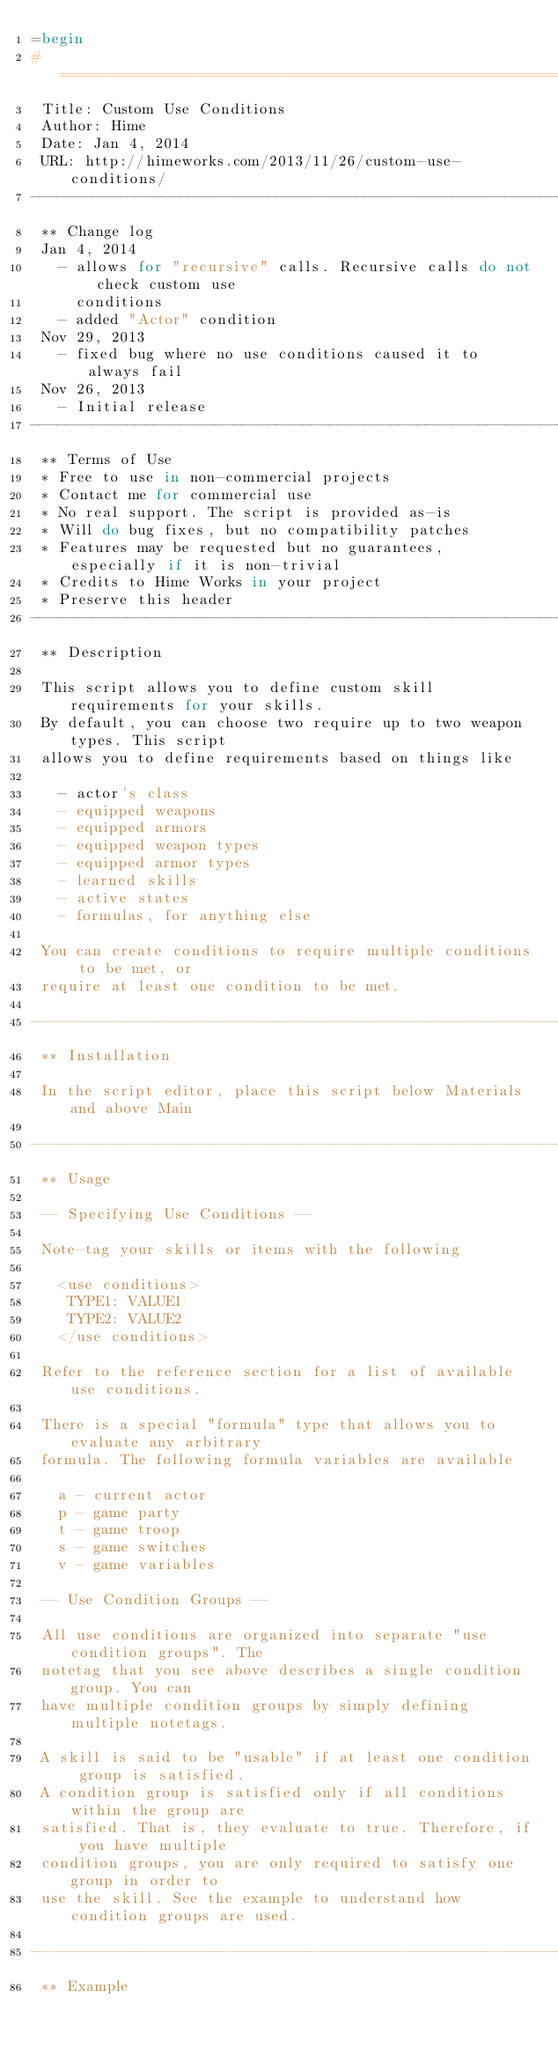Convert code to text. <code><loc_0><loc_0><loc_500><loc_500><_Ruby_>=begin
#===============================================================================
 Title: Custom Use Conditions
 Author: Hime
 Date: Jan 4, 2014
 URL: http://himeworks.com/2013/11/26/custom-use-conditions/
--------------------------------------------------------------------------------
 ** Change log
 Jan 4, 2014
   - allows for "recursive" calls. Recursive calls do not check custom use
     conditions
   - added "Actor" condition
 Nov 29, 2013
   - fixed bug where no use conditions caused it to always fail
 Nov 26, 2013
   - Initial release
--------------------------------------------------------------------------------   
 ** Terms of Use
 * Free to use in non-commercial projects
 * Contact me for commercial use
 * No real support. The script is provided as-is
 * Will do bug fixes, but no compatibility patches
 * Features may be requested but no guarantees, especially if it is non-trivial
 * Credits to Hime Works in your project
 * Preserve this header
--------------------------------------------------------------------------------
 ** Description
 
 This script allows you to define custom skill requirements for your skills.
 By default, you can choose two require up to two weapon types. This script
 allows you to define requirements based on things like
 
   - actor's class
   - equipped weapons
   - equipped armors
   - equipped weapon types
   - equipped armor types
   - learned skills
   - active states
   - formulas, for anything else
   
 You can create conditions to require multiple conditions to be met, or
 require at least one condition to be met.
 
--------------------------------------------------------------------------------
 ** Installation
 
 In the script editor, place this script below Materials and above Main

--------------------------------------------------------------------------------
 ** Usage
 
 -- Specifying Use Conditions --
 
 Note-tag your skills or items with the following
 
   <use conditions>
    TYPE1: VALUE1
    TYPE2: VALUE2
   </use conditions>
   
 Refer to the reference section for a list of available use conditions.
 
 There is a special "formula" type that allows you to evaluate any arbitrary
 formula. The following formula variables are available
 
   a - current actor
   p - game party
   t - game troop
   s - game switches
   v - game variables
   
 -- Use Condition Groups --
 
 All use conditions are organized into separate "use condition groups". The
 notetag that you see above describes a single condition group. You can
 have multiple condition groups by simply defining multiple notetags.
 
 A skill is said to be "usable" if at least one condition group is satisfied. 
 A condition group is satisfied only if all conditions within the group are
 satisfied. That is, they evaluate to true. Therefore, if you have multiple
 condition groups, you are only required to satisfy one group in order to
 use the skill. See the example to understand how condition groups are used.

-------------------------------------------------------------------------------- 
 ** Example
 </code> 